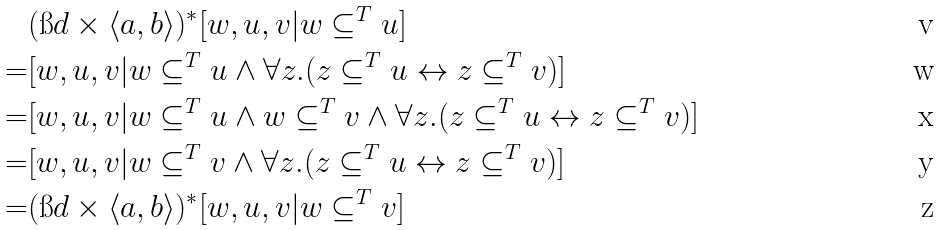Convert formula to latex. <formula><loc_0><loc_0><loc_500><loc_500>& ( \i d \times \langle a , b \rangle ) ^ { * } [ w , u , v | w \subseteq ^ { T } u ] \\ = & [ w , u , v | w \subseteq ^ { T } u \wedge \forall z . ( z \subseteq ^ { T } u \leftrightarrow z \subseteq ^ { T } v ) ] \\ = & [ w , u , v | w \subseteq ^ { T } u \wedge w \subseteq ^ { T } v \wedge \forall z . ( z \subseteq ^ { T } u \leftrightarrow z \subseteq ^ { T } v ) ] \\ = & [ w , u , v | w \subseteq ^ { T } v \wedge \forall z . ( z \subseteq ^ { T } u \leftrightarrow z \subseteq ^ { T } v ) ] \\ = & ( \i d \times \langle a , b \rangle ) ^ { * } [ w , u , v | w \subseteq ^ { T } v ]</formula> 